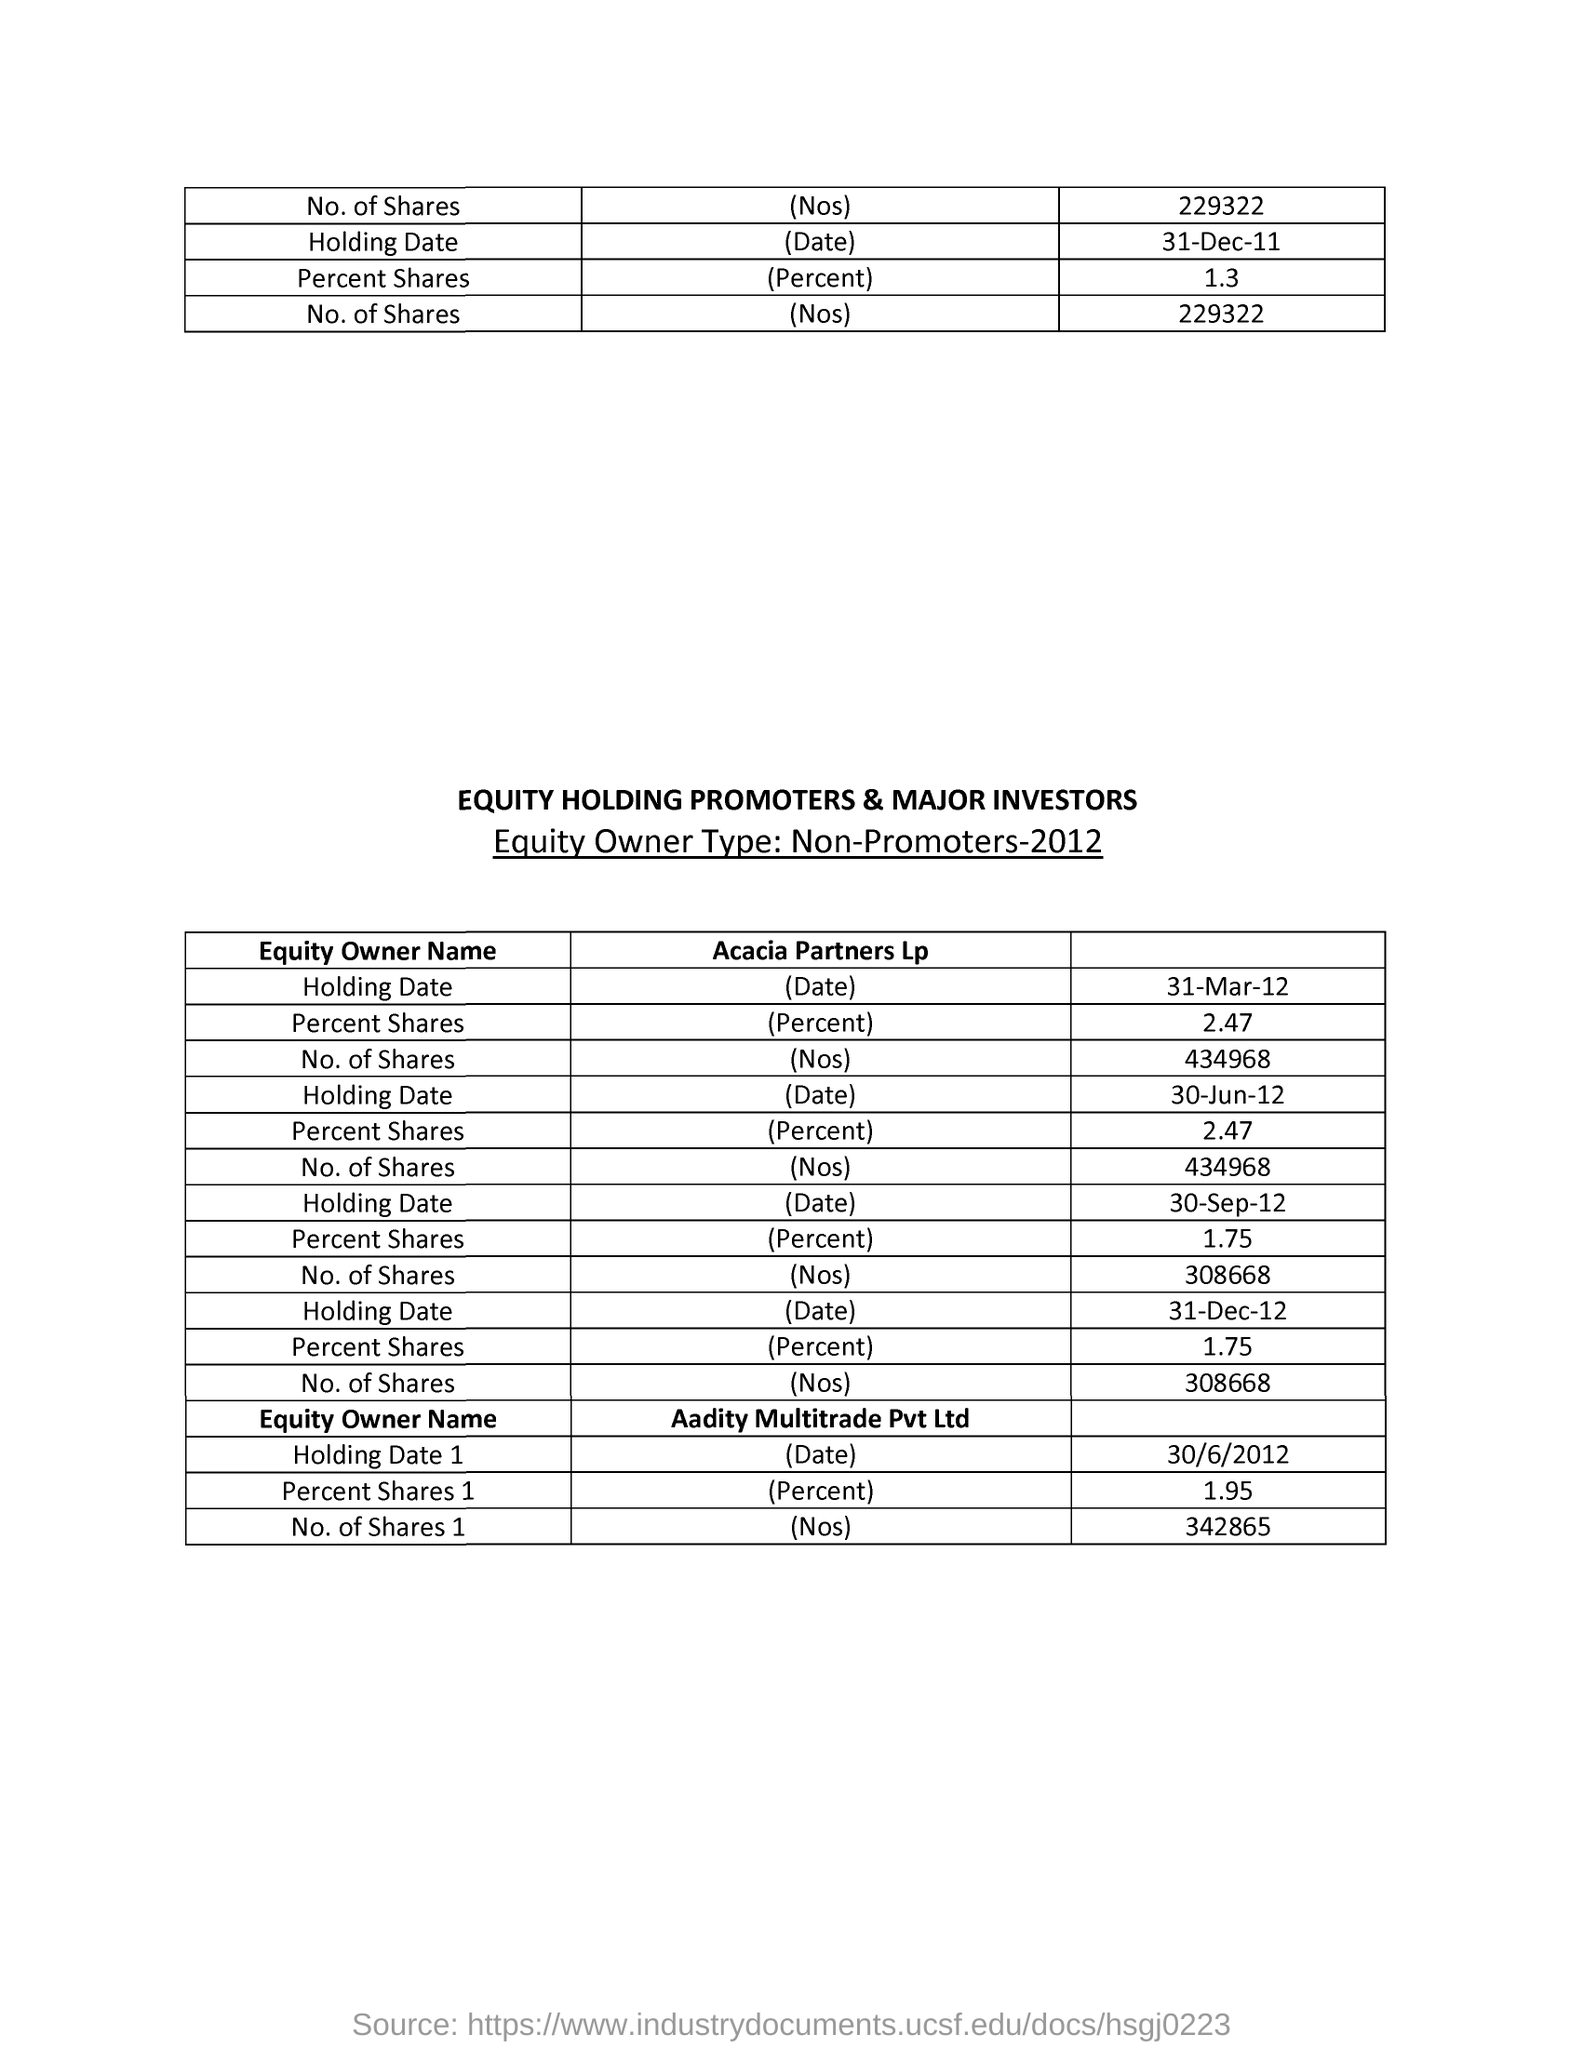What percent of shares aadity multitrade pvt ltd hold?
Provide a succinct answer. 1.95. What is the total number of shares in aadity multitrade pvt ltd?
Provide a short and direct response. 342865. 